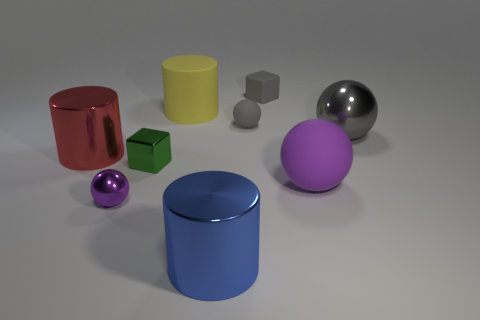How do the textures of the objects in the image differ? The textures vary significantly; the metallic sphere has a reflective surface, while the rubber cylinder and other objects exhibit a more matte finish, diffusing the light that hits them. 